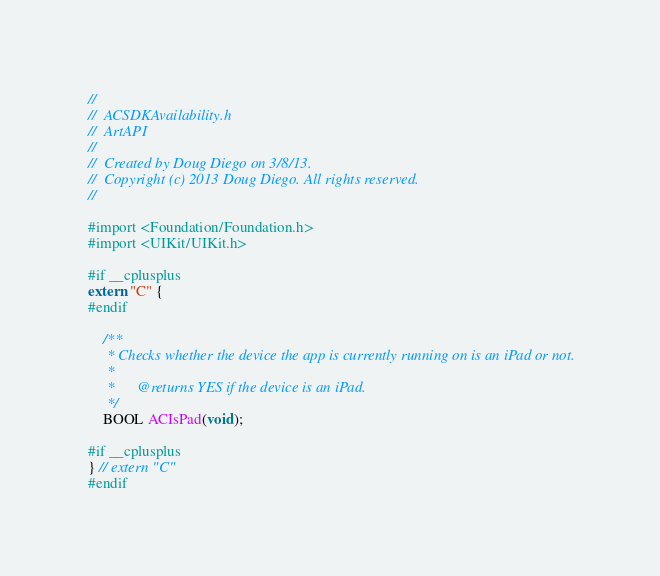Convert code to text. <code><loc_0><loc_0><loc_500><loc_500><_C_>//
//  ACSDKAvailability.h
//  ArtAPI
//
//  Created by Doug Diego on 3/8/13.
//  Copyright (c) 2013 Doug Diego. All rights reserved.
//

#import <Foundation/Foundation.h>
#import <UIKit/UIKit.h>

#if __cplusplus
extern "C" {
#endif
    
    /**
     * Checks whether the device the app is currently running on is an iPad or not.
     *
     *      @returns YES if the device is an iPad.
     */
    BOOL ACIsPad(void);

#if __cplusplus
} // extern "C"
#endif</code> 